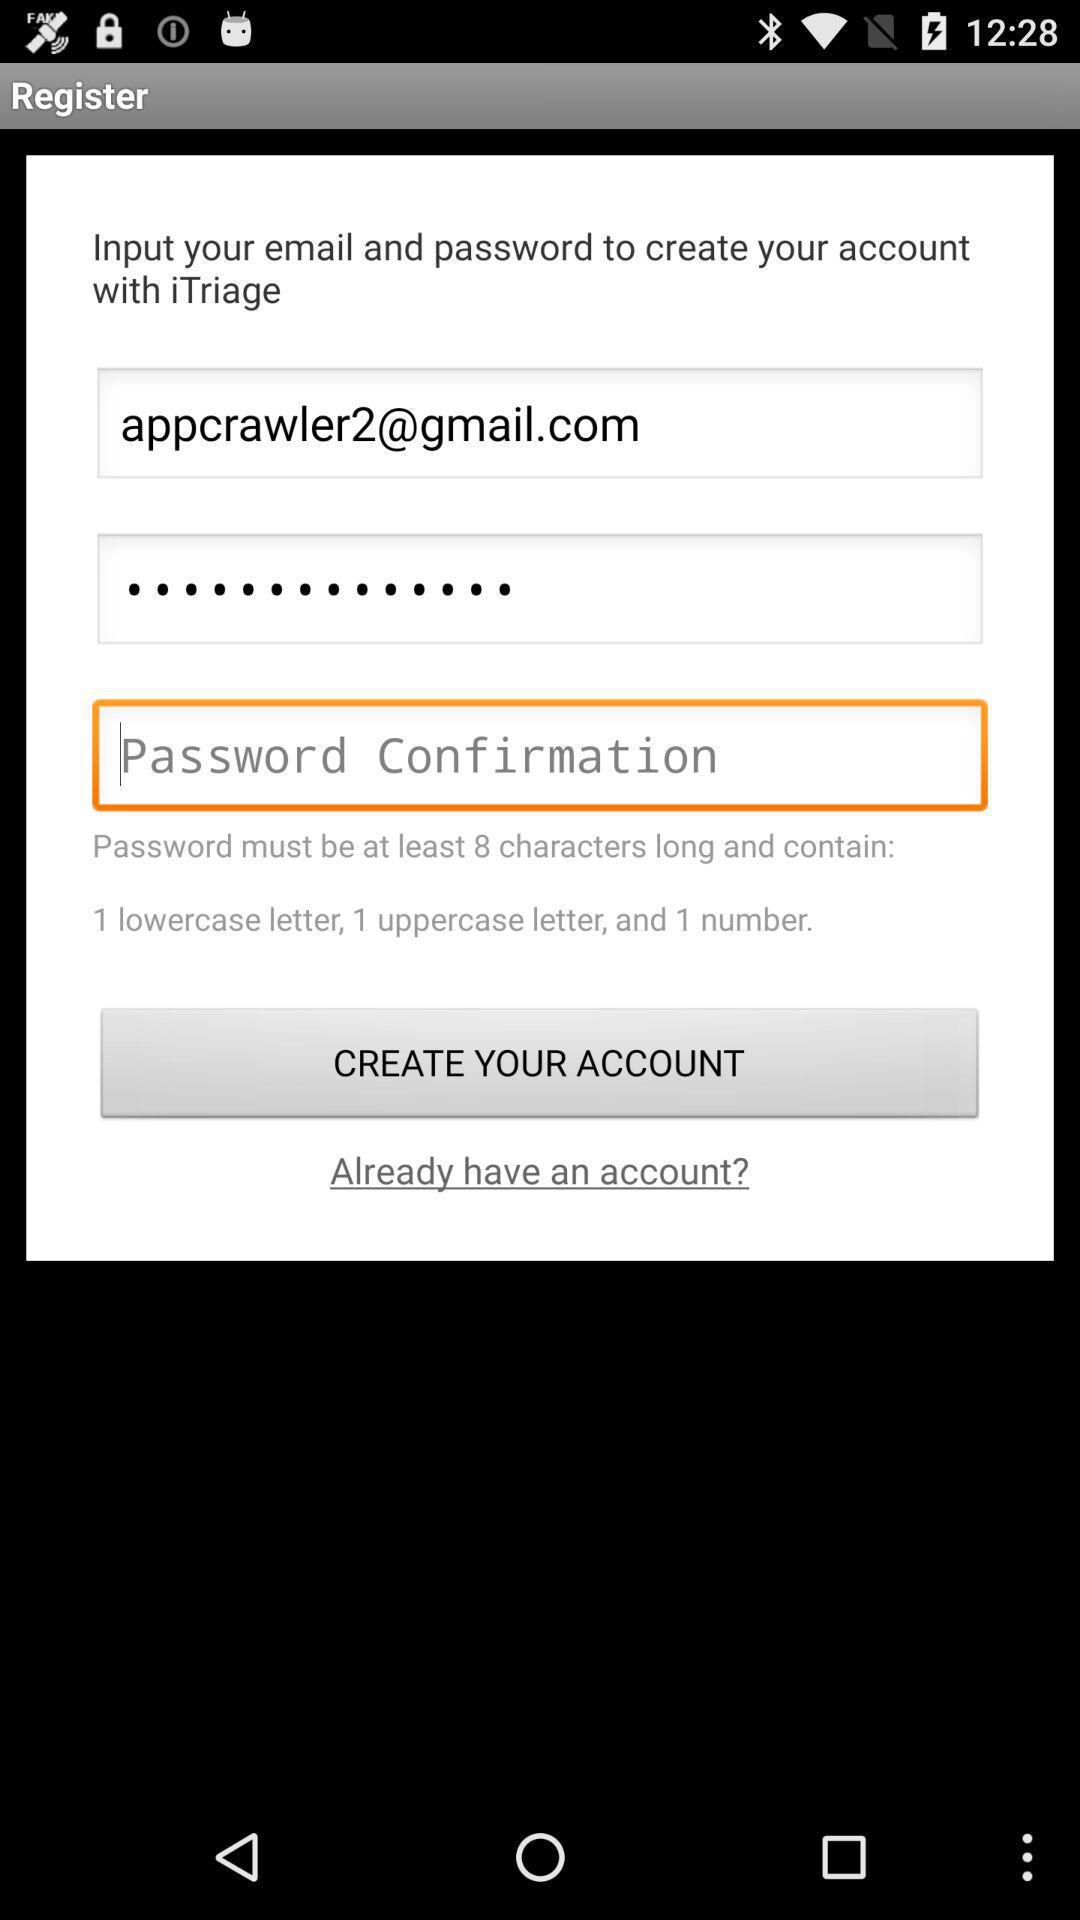What is the email address? The email address is appcrawler2@gmail.com. 